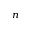<formula> <loc_0><loc_0><loc_500><loc_500>_ { n }</formula> 